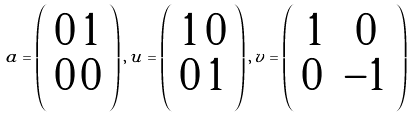Convert formula to latex. <formula><loc_0><loc_0><loc_500><loc_500>a = \left ( \begin{array} { c c } 0 \, 1 \\ 0 \, 0 \end{array} \right ) , \, u = \left ( \begin{array} { c c } 1 \, 0 \\ 0 \, 1 \end{array} \right ) , \, v = \left ( \begin{array} { c c } 1 & 0 \\ 0 \, & - 1 \end{array} \right )</formula> 